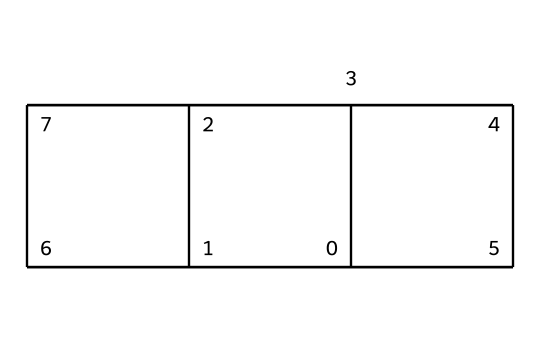How many carbon atoms are present in cubane? The SMILES representation indicates a total of eight carbon atoms are connected in a cubic arrangement, corresponding to the 'C' characters in the string.
Answer: eight What is the molecular formula of cubane? By analyzing the SMILES string, it shows there are 8 carbon atoms and 8 hydrogen atoms based on typical bonding patterns for saturated hydrocarbons. Hence, the molecular formula is C8H8.
Answer: C8H8 Is cubane a saturated or unsaturated compound? The structure based on the SMILES shows all carbon atoms are bonded with single bonds only, indicating that it is a saturated compound.
Answer: saturated What type of compound is cubane classified as? Cubane belongs to the class of cage compounds, which are characterized by a closed three-dimensional structure; specifically, it falls into the category of cubic hydrocarbons.
Answer: cage compound How many hydrogen atoms are connected to each carbon in cubane? Given the cubane structure from the SMILES, each carbon is bonded to two other carbons and two hydrogens, adhering to tetravalency in carbon, which stipulates a total of 8 hydrogen atoms for the molecule.
Answer: two What is the potential application of cubane in energy? Cubane is being researched as a possible high-energy fuel additive due to its unique molecular structure that allows for high energy density and efficient combustion.
Answer: fuel additive 